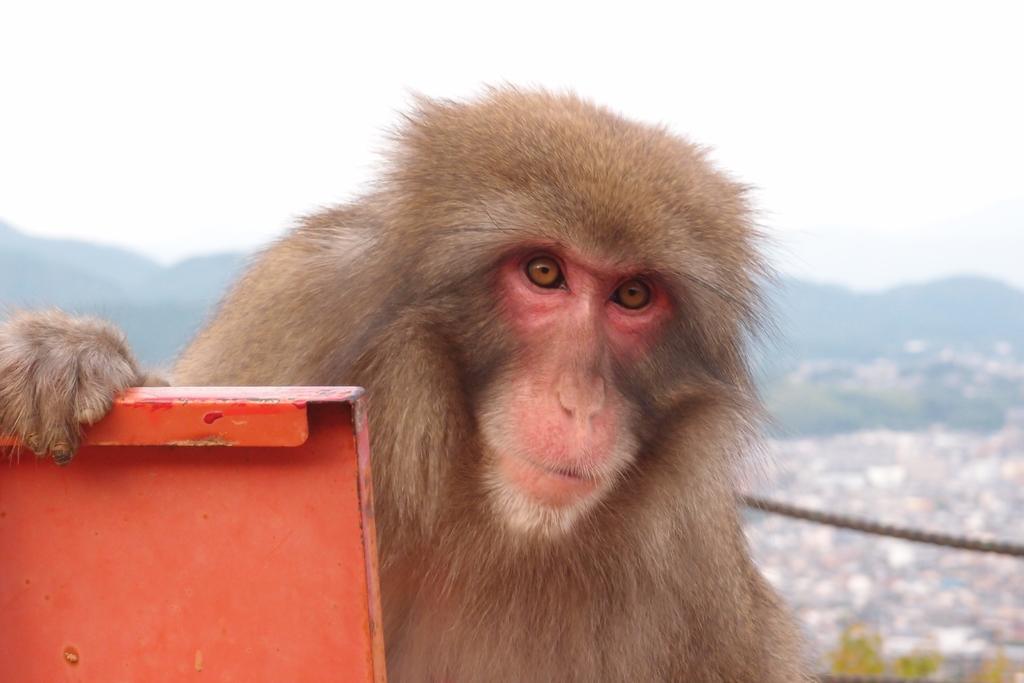Could you give a brief overview of what you see in this image? In this picture there is a monkey in the center of the image and there is a board on the left side of the image. 